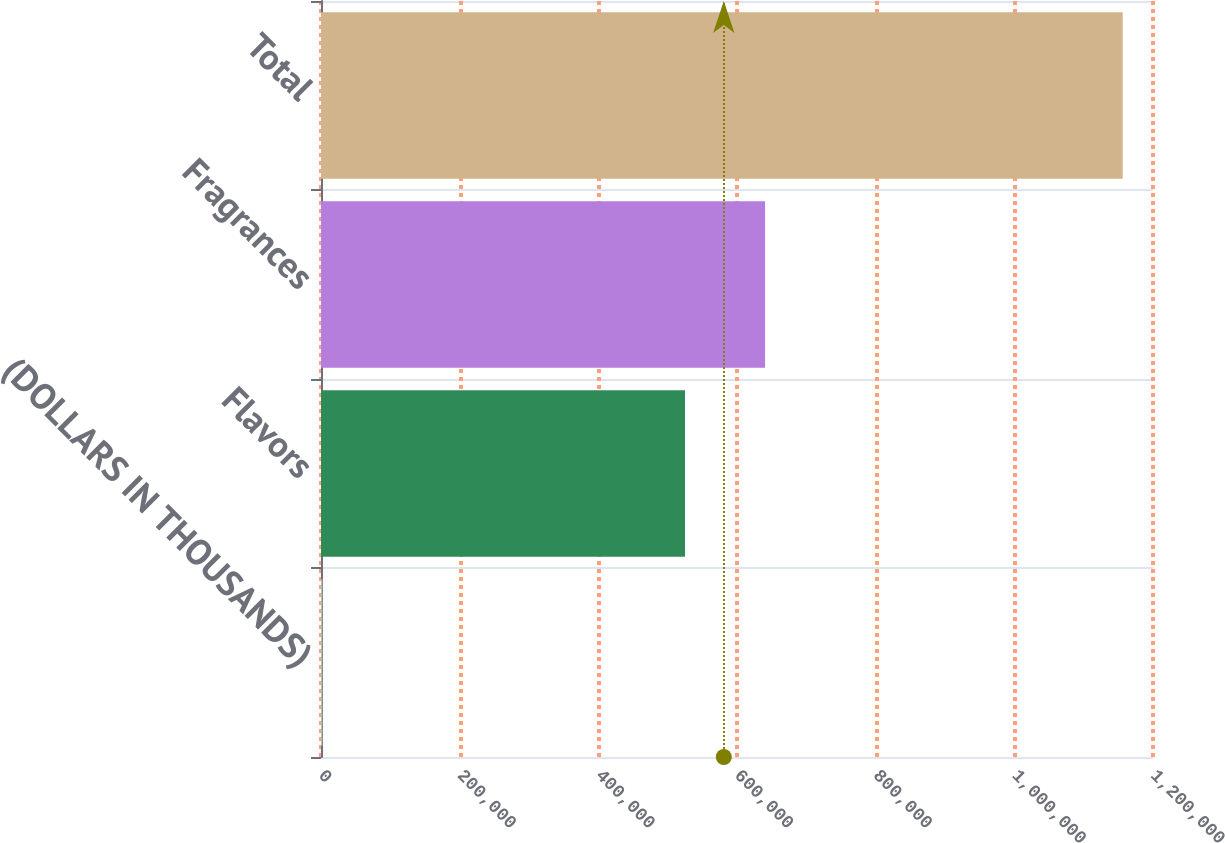Convert chart. <chart><loc_0><loc_0><loc_500><loc_500><bar_chart><fcel>(DOLLARS IN THOUSANDS)<fcel>Flavors<fcel>Fragrances<fcel>Total<nl><fcel>2017<fcel>525038<fcel>640465<fcel>1.15629e+06<nl></chart> 